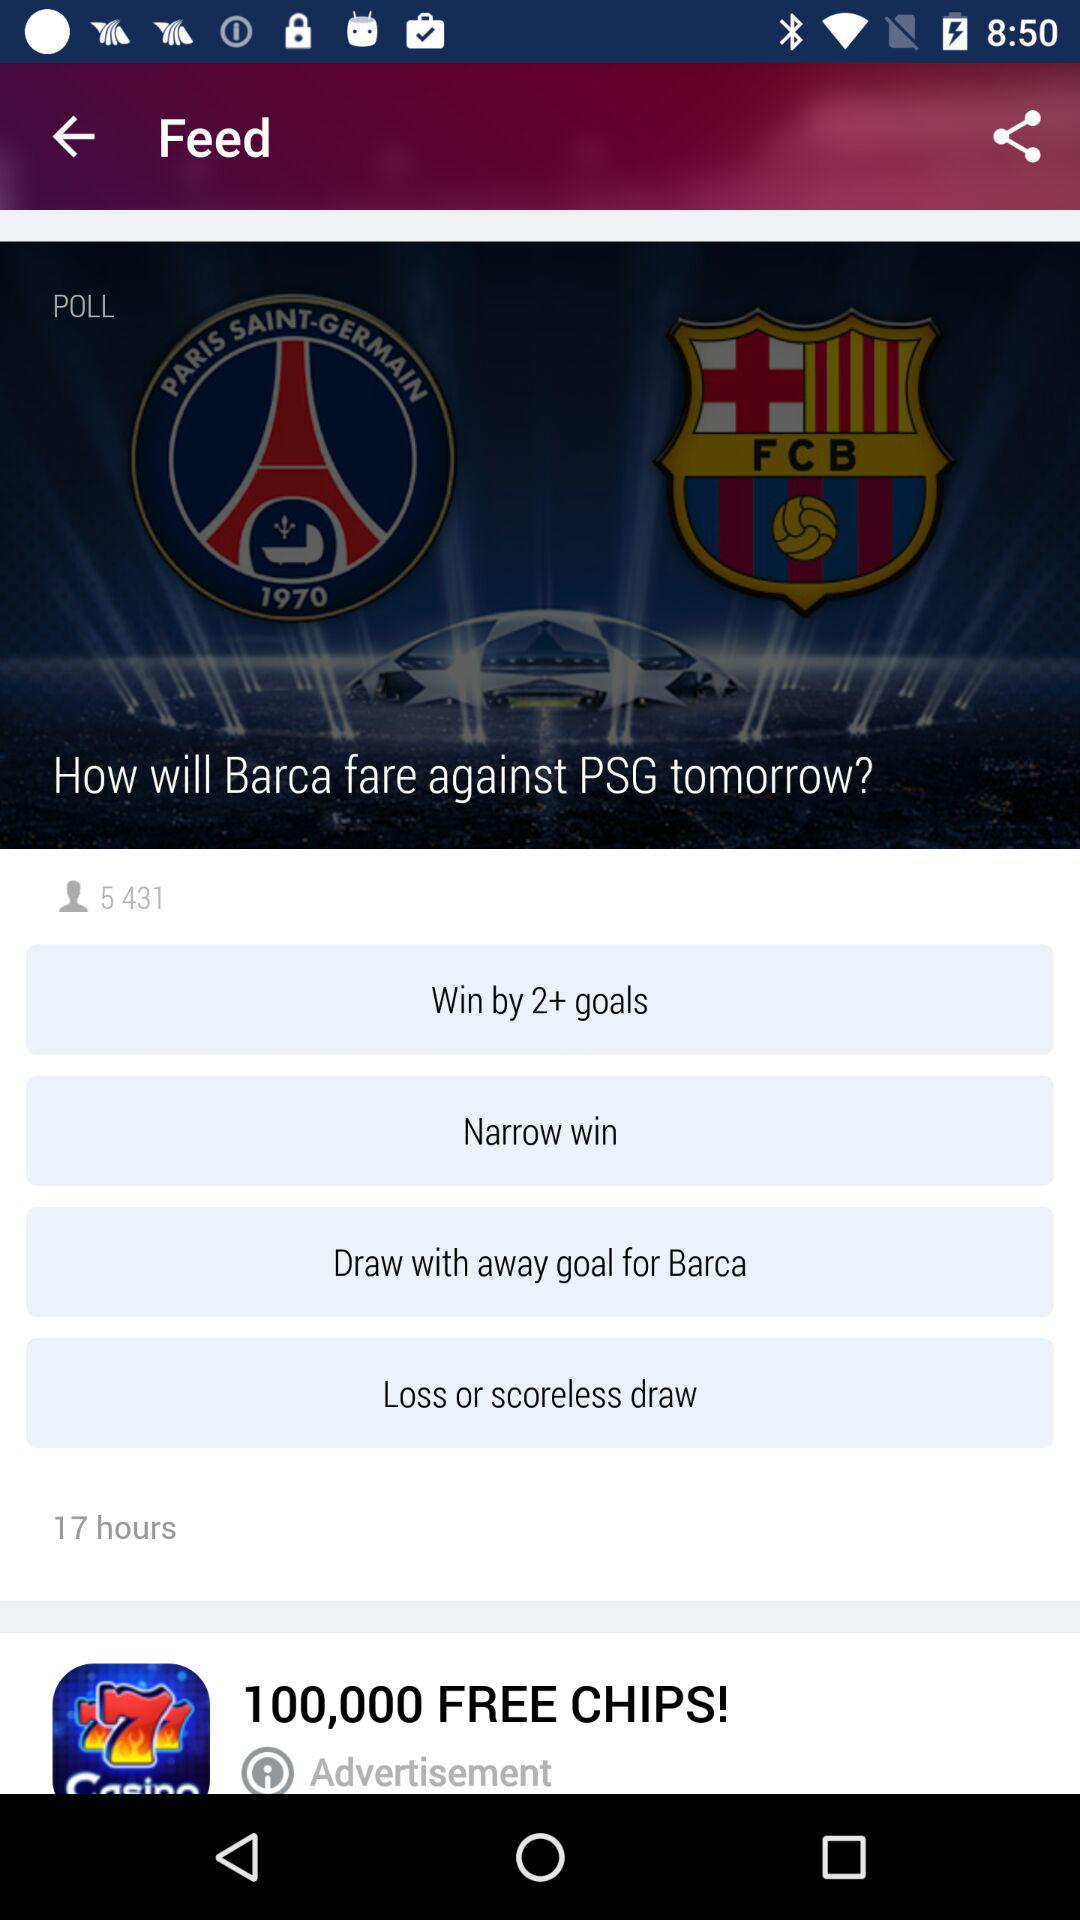How many options are there to vote for in the poll?
Answer the question using a single word or phrase. 4 